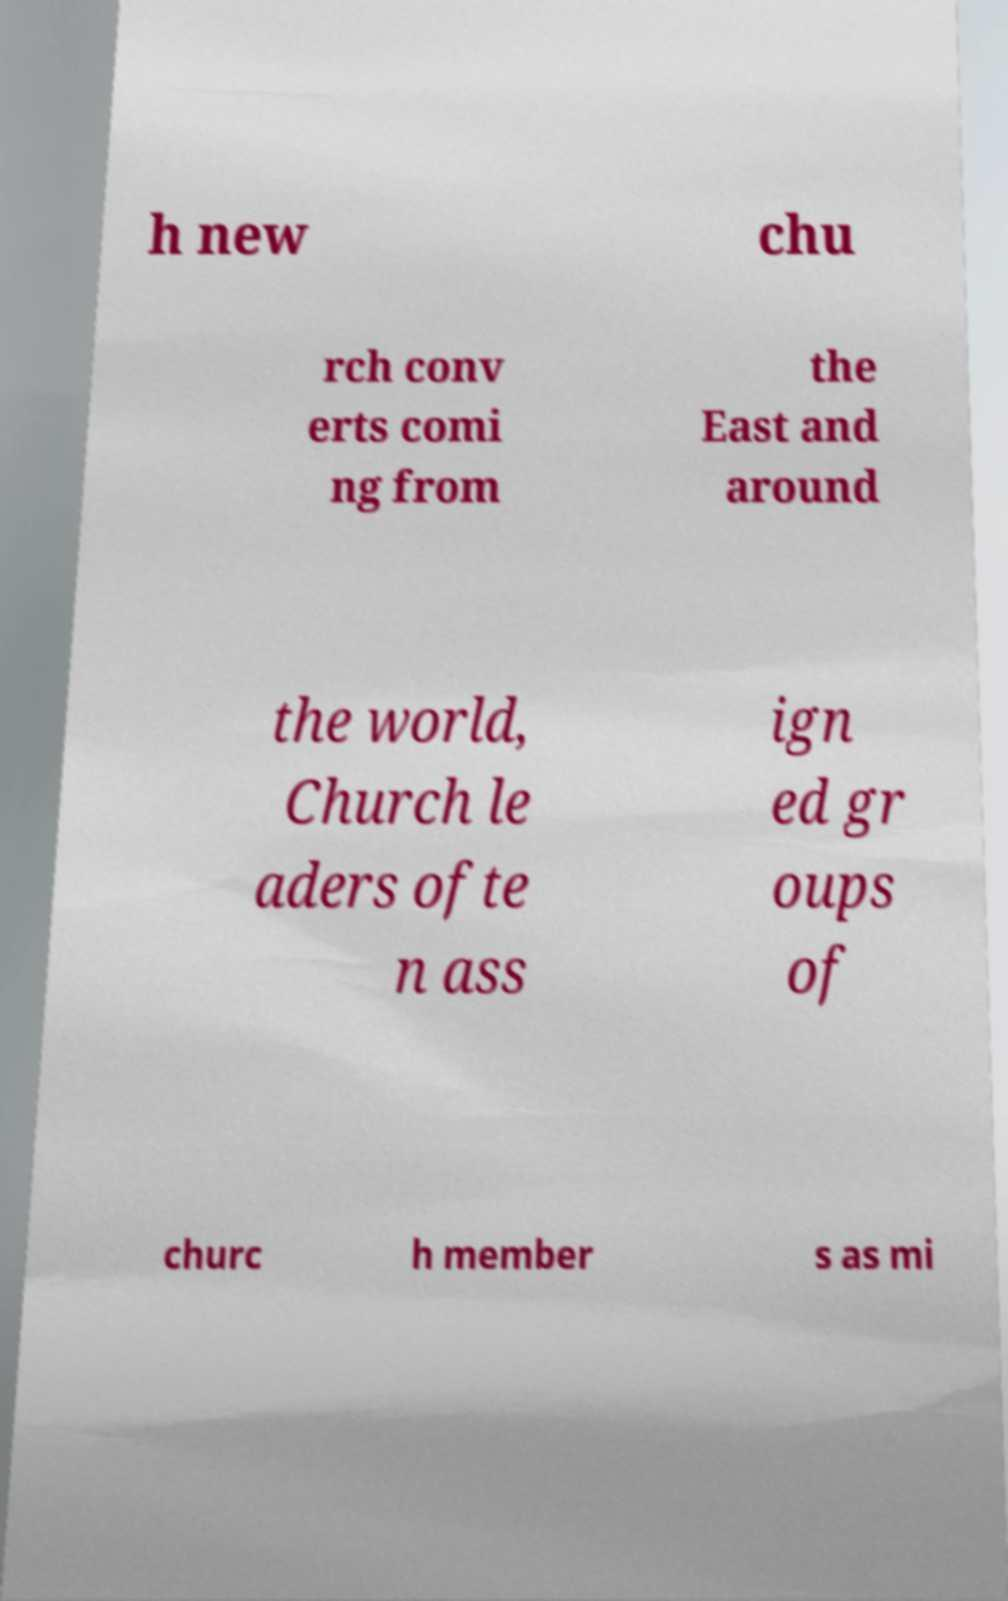Could you extract and type out the text from this image? h new chu rch conv erts comi ng from the East and around the world, Church le aders ofte n ass ign ed gr oups of churc h member s as mi 